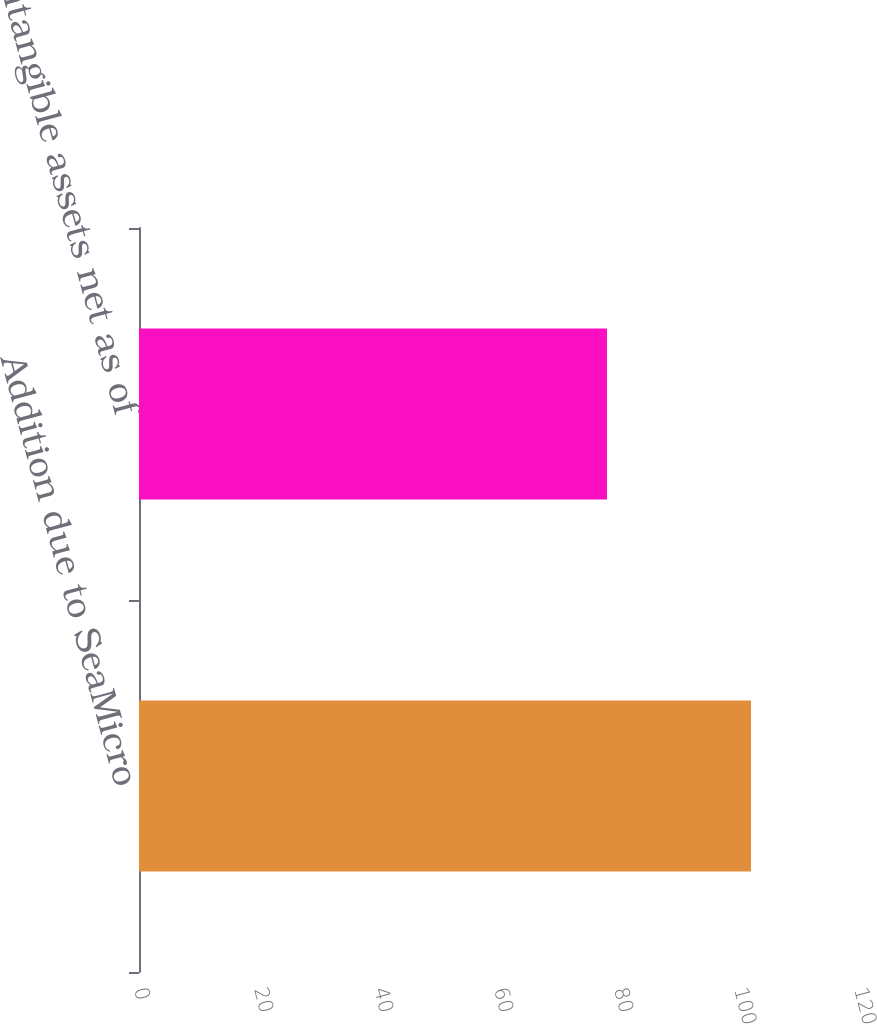<chart> <loc_0><loc_0><loc_500><loc_500><bar_chart><fcel>Addition due to SeaMicro<fcel>Intangible assets net as of<nl><fcel>102<fcel>78<nl></chart> 